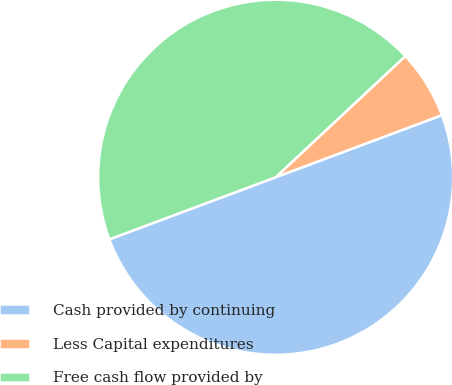Convert chart. <chart><loc_0><loc_0><loc_500><loc_500><pie_chart><fcel>Cash provided by continuing<fcel>Less Capital expenditures<fcel>Free cash flow provided by<nl><fcel>50.0%<fcel>6.27%<fcel>43.73%<nl></chart> 